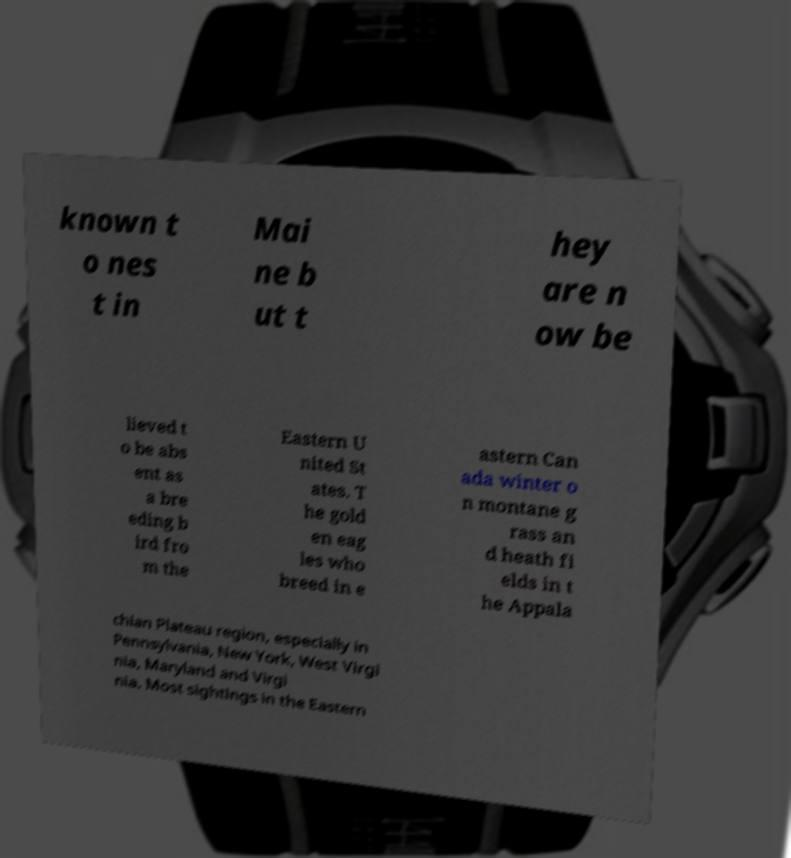Can you read and provide the text displayed in the image?This photo seems to have some interesting text. Can you extract and type it out for me? known t o nes t in Mai ne b ut t hey are n ow be lieved t o be abs ent as a bre eding b ird fro m the Eastern U nited St ates. T he gold en eag les who breed in e astern Can ada winter o n montane g rass an d heath fi elds in t he Appala chian Plateau region, especially in Pennsylvania, New York, West Virgi nia, Maryland and Virgi nia. Most sightings in the Eastern 